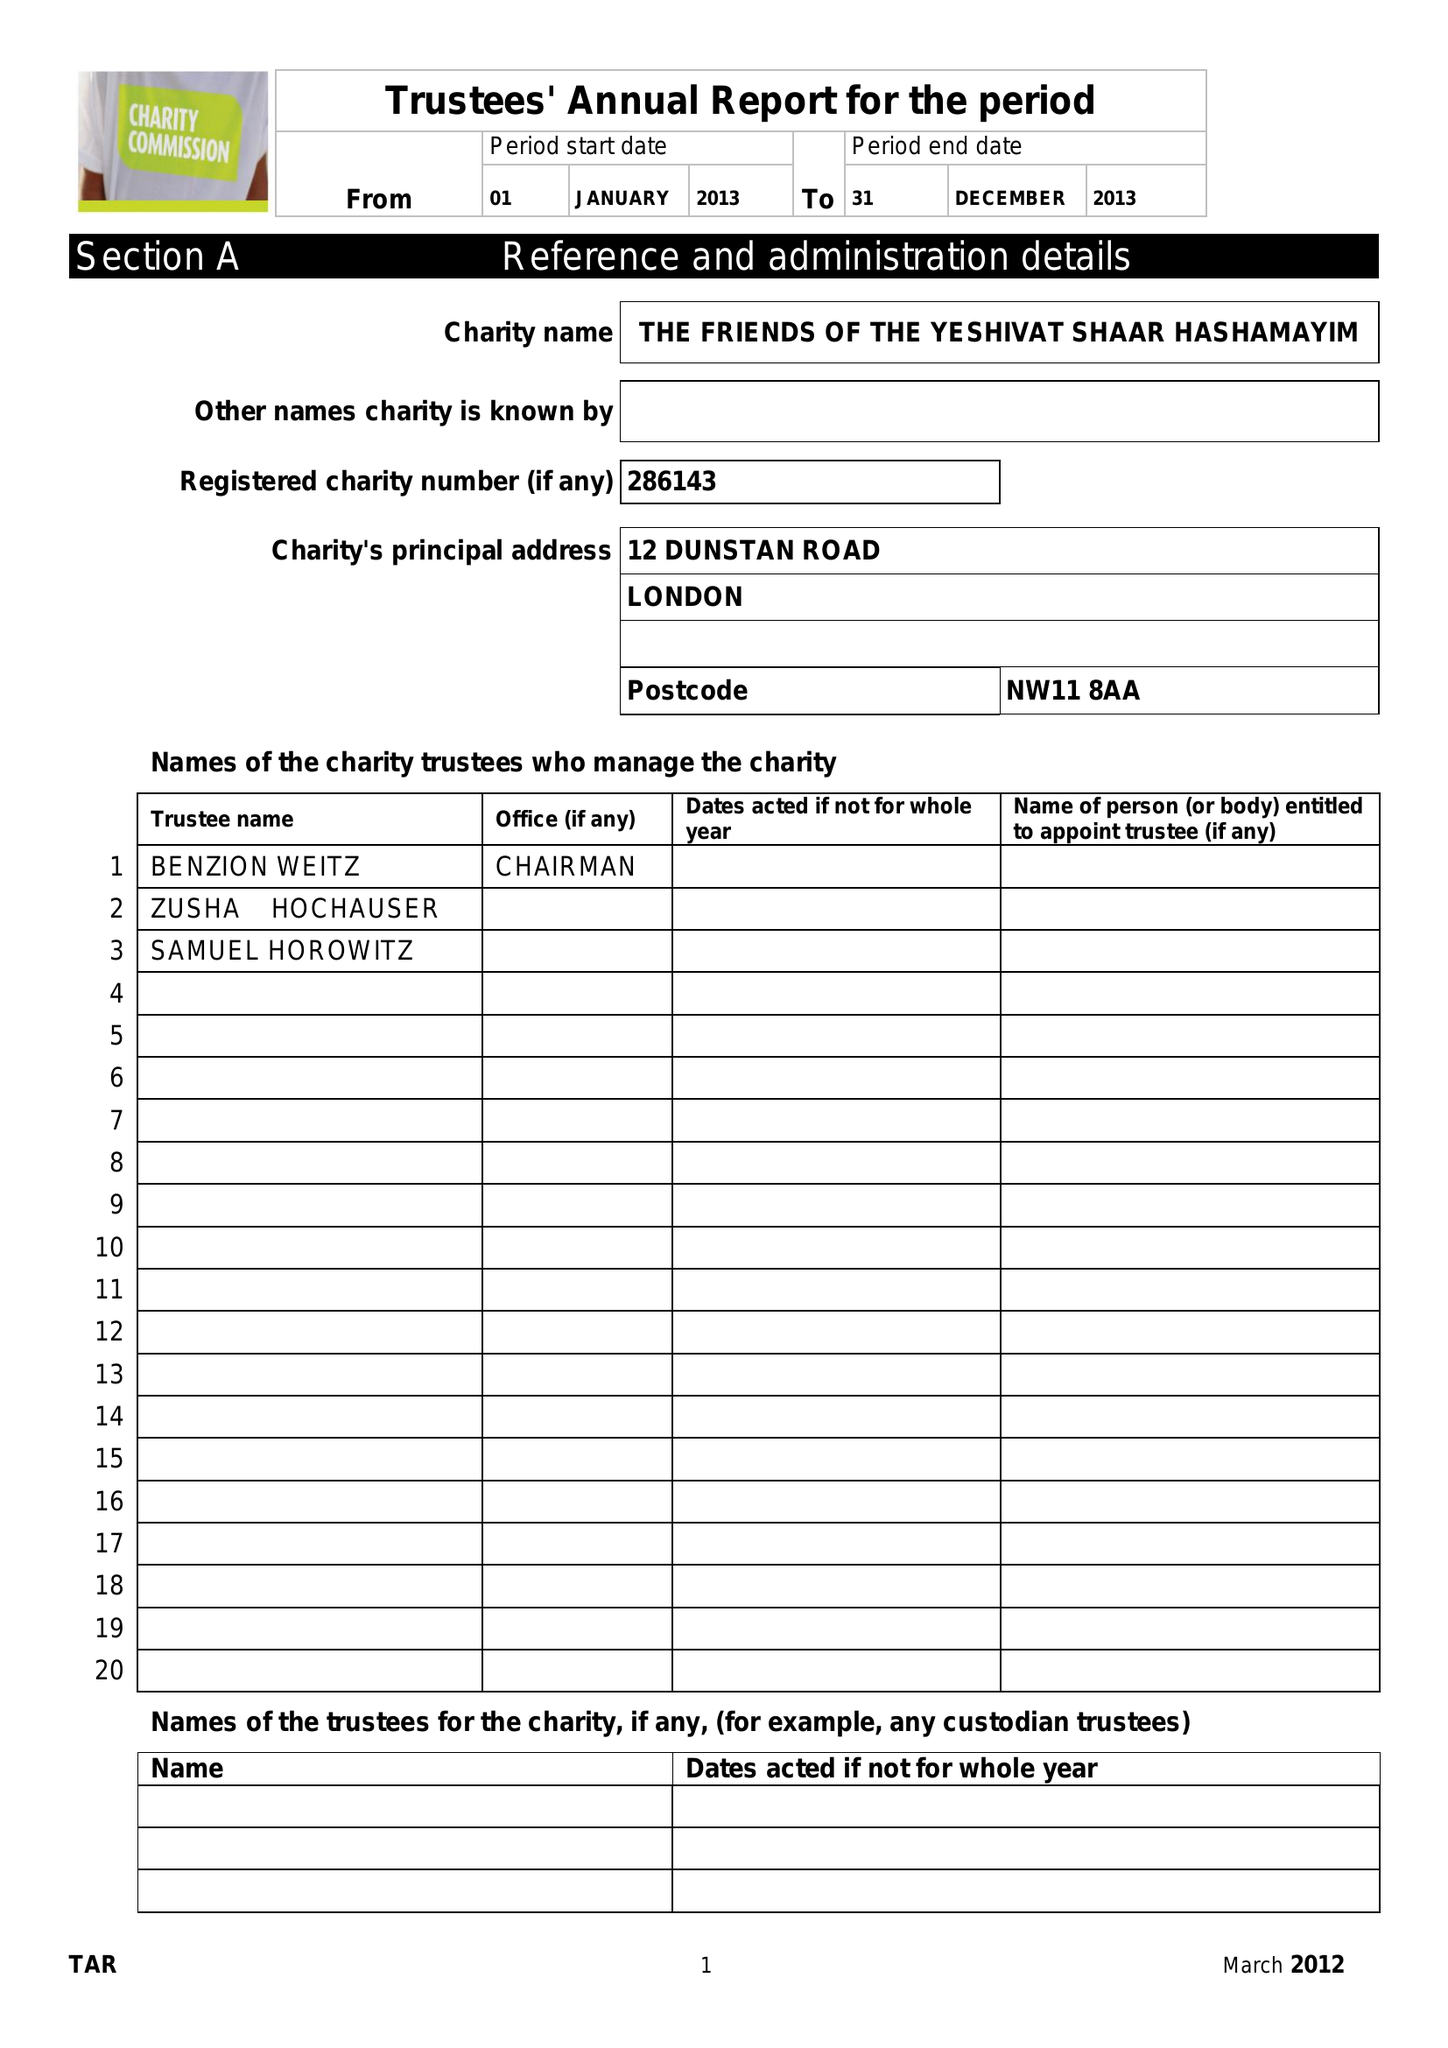What is the value for the address__street_line?
Answer the question using a single word or phrase. 12 DUNSTAN ROAD 